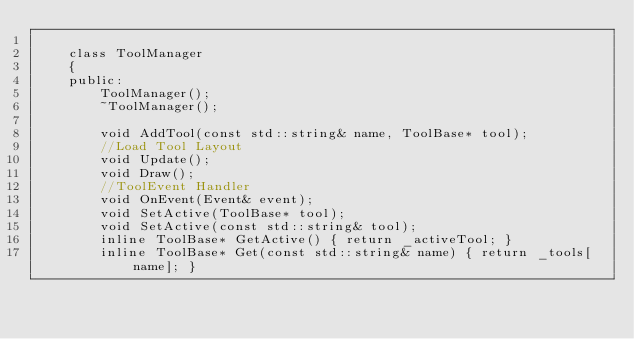Convert code to text. <code><loc_0><loc_0><loc_500><loc_500><_C_>
	class ToolManager
	{
	public:
		ToolManager();
		~ToolManager();

		void AddTool(const std::string& name, ToolBase* tool);
		//Load Tool Layout
		void Update();
		void Draw();
		//ToolEvent Handler
		void OnEvent(Event& event);
		void SetActive(ToolBase* tool);
		void SetActive(const std::string& tool);
		inline ToolBase* GetActive() { return _activeTool; }
		inline ToolBase* Get(const std::string& name) { return _tools[name]; }</code> 